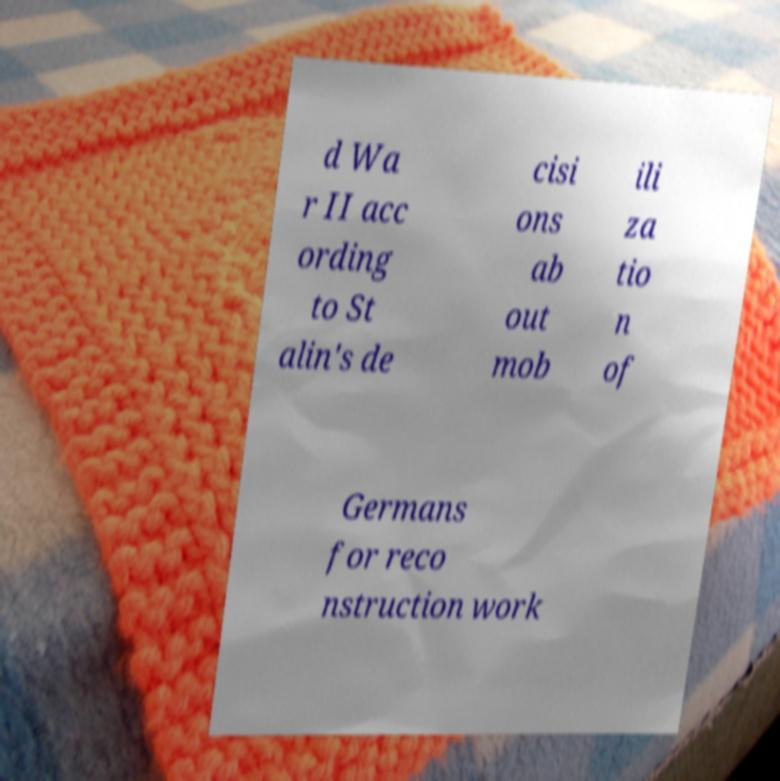Can you accurately transcribe the text from the provided image for me? d Wa r II acc ording to St alin's de cisi ons ab out mob ili za tio n of Germans for reco nstruction work 